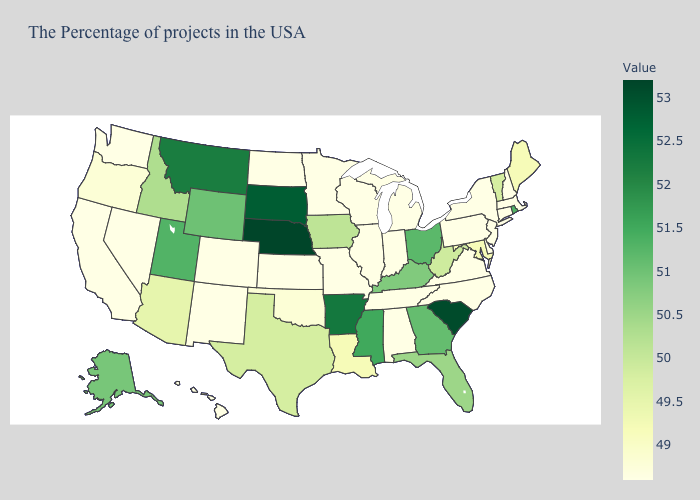Does Nebraska have the highest value in the MidWest?
Quick response, please. Yes. 